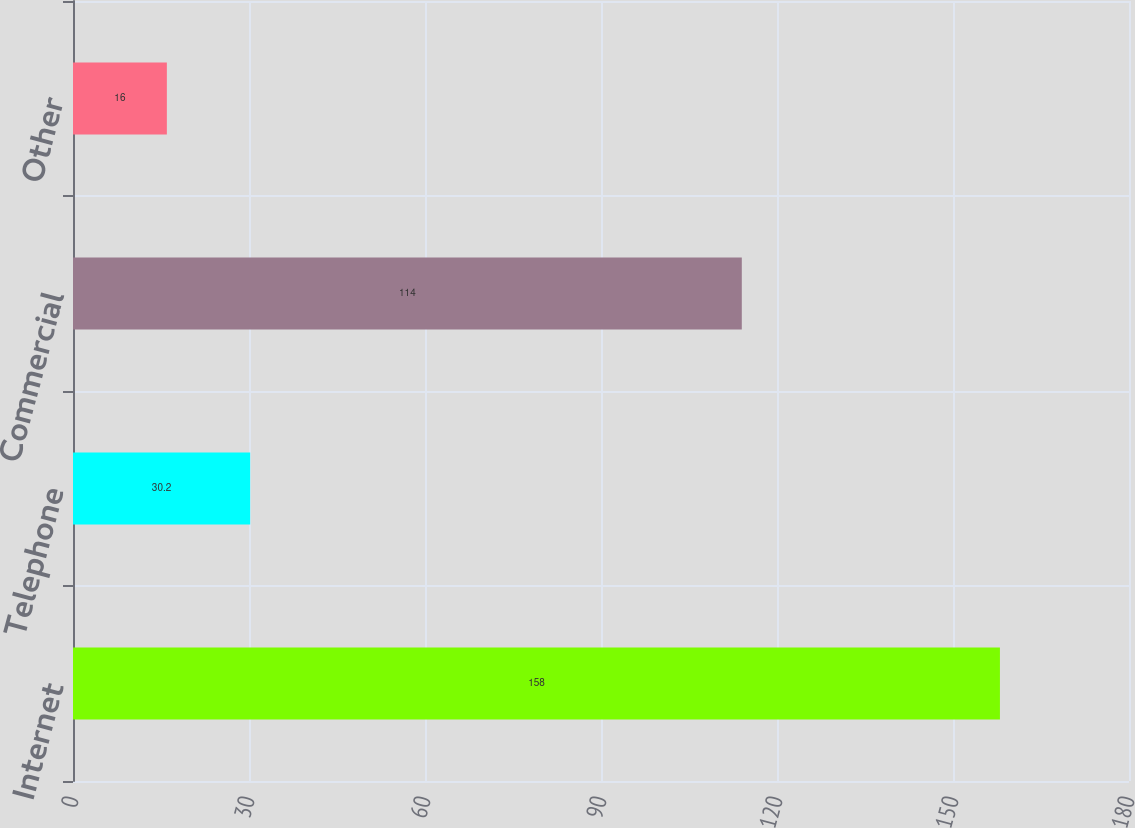<chart> <loc_0><loc_0><loc_500><loc_500><bar_chart><fcel>Internet<fcel>Telephone<fcel>Commercial<fcel>Other<nl><fcel>158<fcel>30.2<fcel>114<fcel>16<nl></chart> 